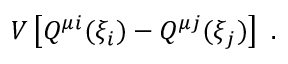Convert formula to latex. <formula><loc_0><loc_0><loc_500><loc_500>V \left [ Q ^ { \mu i } ( \xi _ { i } ) - Q ^ { \mu j } ( \xi _ { j } ) \right ] \ .</formula> 